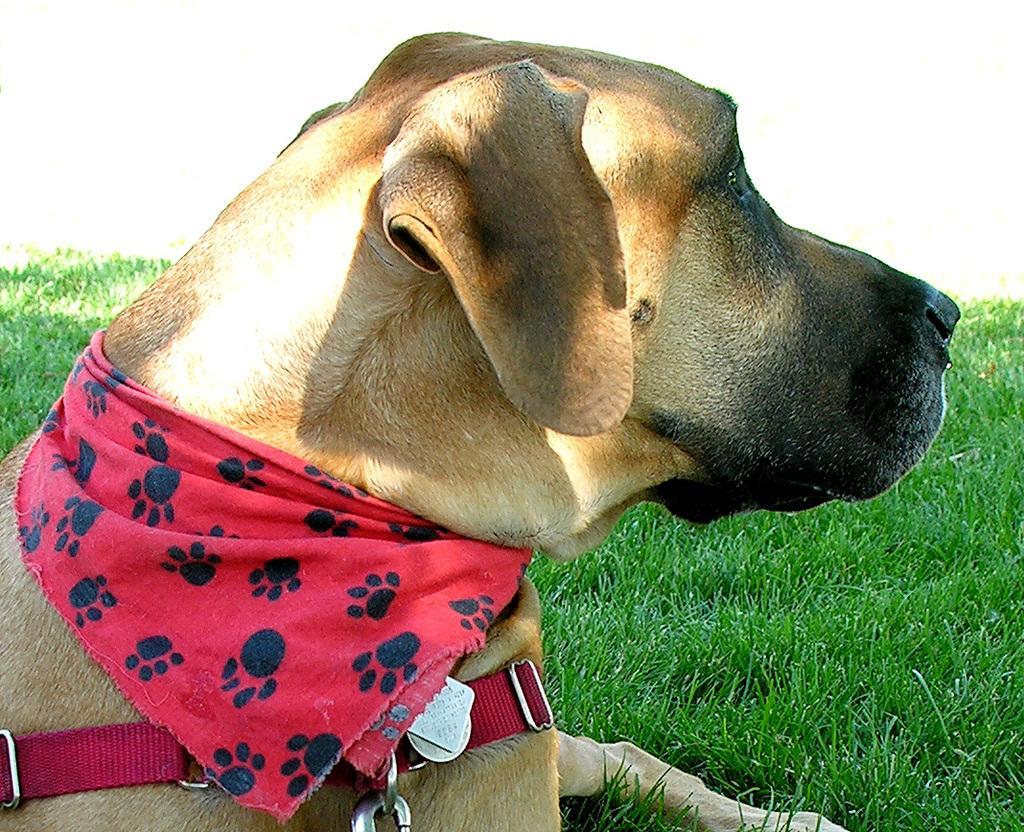Can you describe this image briefly? In this picture we can the side view of a dog with a red belt and a red scarf around its neck. It is sitting on the green grass and is looking somewhere. 